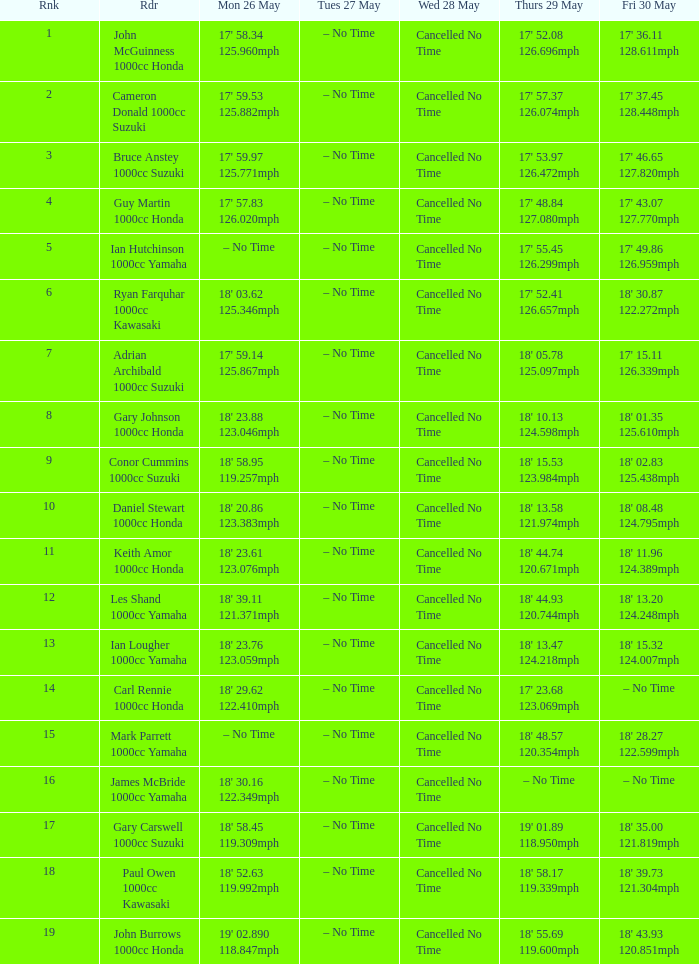At what moment is mon may 26 and fri may 30 at 18' 2 – No Time. 